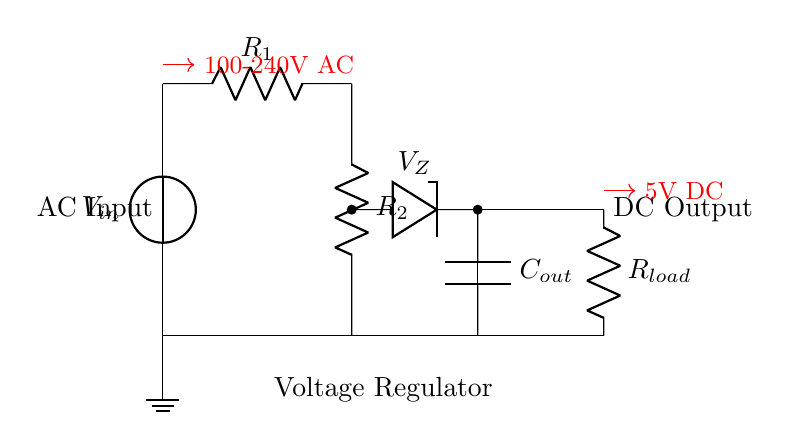What is the input voltage of this circuit? The input voltage is specified as 100-240V AC, which is indicated next to the AC input source in the circuit.
Answer: 100-240V AC What is the output voltage of this circuit? The output voltage is stated as 5V DC, which is shown next to the output node in the circuit diagram.
Answer: 5V DC What type of diode is used in this circuit? A Zener diode is used, which is denoted in the diagram with the symbol for a Zener diode, indicated by the notation V_Z.
Answer: Zener What components make up the voltage regulator circuit? The components include a voltage source, resistors, a Zener diode, and a capacitor. Each is represented with their respective symbols and labels in the circuit.
Answer: Voltage source, resistors, Zener diode, capacitor How does the Zener diode regulate the output voltage? The Zener diode allows current to flow in the reverse direction when the input voltage exceeds the Zener breakdown voltage, maintaining a constant voltage level at the output. This feedback mechanism stabilizes the output despite variations in the input.
Answer: By keeping a constant voltage level What is the purpose of the output capacitor in this circuit? The output capacitor is used to smooth the output voltage and reduce voltage fluctuations caused by load changes or ripple in the circuit. This improves the stability and performance of the output signal.
Answer: To smooth the output voltage Which components are responsible for voltage division in the circuit? The resistors R1 and R2 form a voltage divider network, allowing a specific fraction of the input voltage to be presented to the Zener diode for regulation. This configuration helps to ensure that the Zener operates within its specified range.
Answer: Resistors R1 and R2 